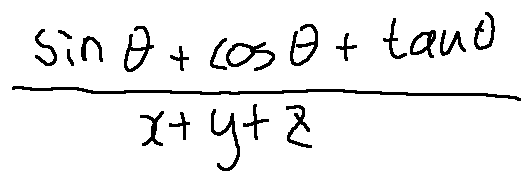Convert formula to latex. <formula><loc_0><loc_0><loc_500><loc_500>\frac { \sin \theta + \cos \theta + \tan \theta } { x + y + z }</formula> 